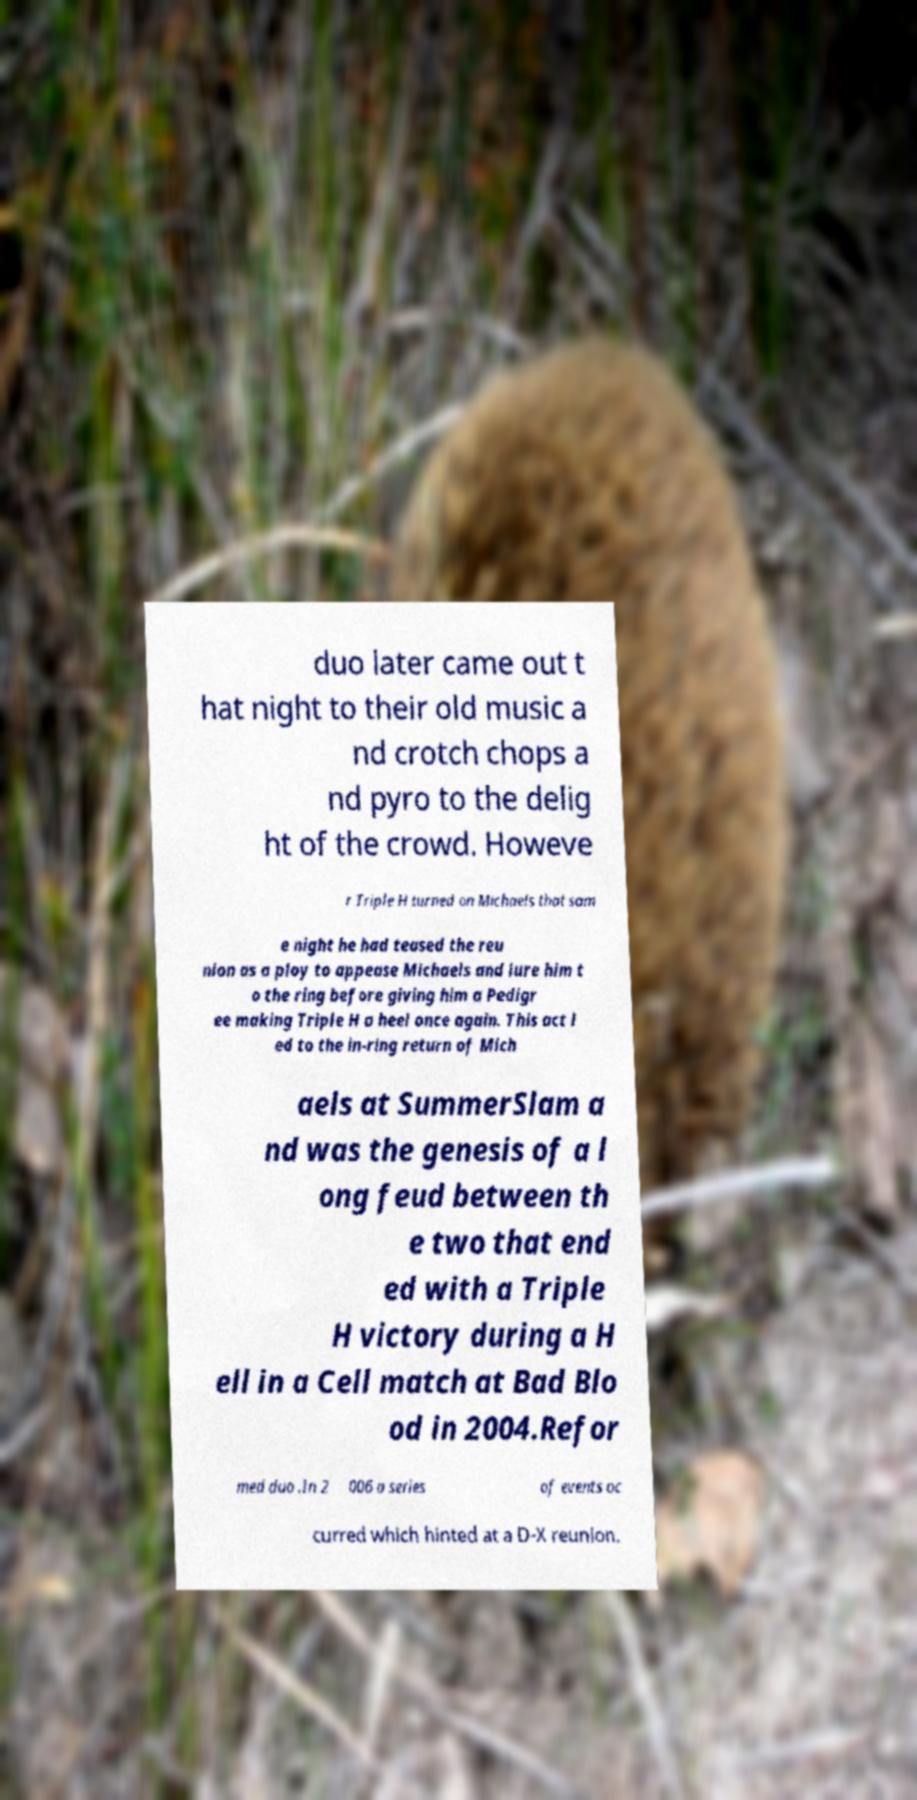What messages or text are displayed in this image? I need them in a readable, typed format. duo later came out t hat night to their old music a nd crotch chops a nd pyro to the delig ht of the crowd. Howeve r Triple H turned on Michaels that sam e night he had teased the reu nion as a ploy to appease Michaels and lure him t o the ring before giving him a Pedigr ee making Triple H a heel once again. This act l ed to the in-ring return of Mich aels at SummerSlam a nd was the genesis of a l ong feud between th e two that end ed with a Triple H victory during a H ell in a Cell match at Bad Blo od in 2004.Refor med duo .In 2 006 a series of events oc curred which hinted at a D-X reunion. 